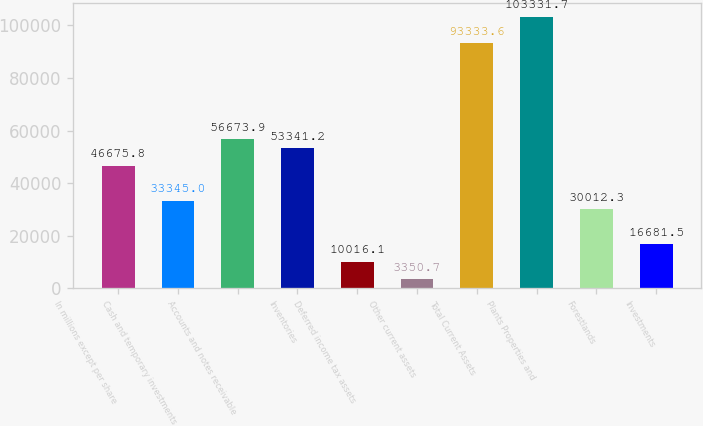Convert chart to OTSL. <chart><loc_0><loc_0><loc_500><loc_500><bar_chart><fcel>In millions except per share<fcel>Cash and temporary investments<fcel>Accounts and notes receivable<fcel>Inventories<fcel>Deferred income tax assets<fcel>Other current assets<fcel>Total Current Assets<fcel>Plants Properties and<fcel>Forestlands<fcel>Investments<nl><fcel>46675.8<fcel>33345<fcel>56673.9<fcel>53341.2<fcel>10016.1<fcel>3350.7<fcel>93333.6<fcel>103332<fcel>30012.3<fcel>16681.5<nl></chart> 